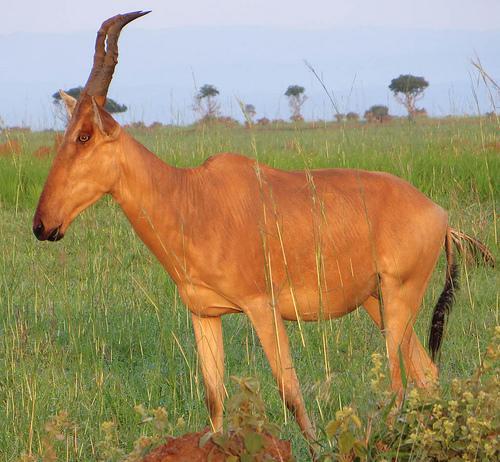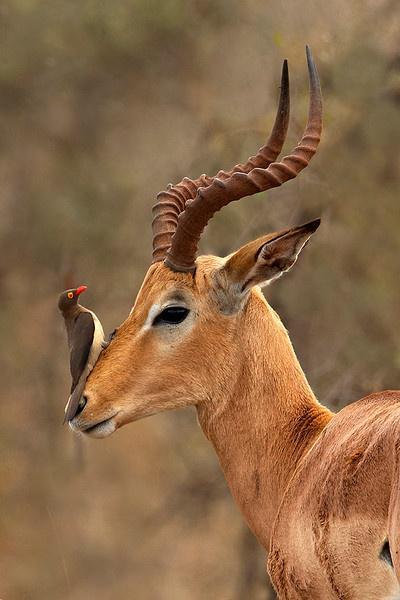The first image is the image on the left, the second image is the image on the right. Analyze the images presented: Is the assertion "At least 7 hartebeests walk down a dirt road." valid? Answer yes or no. No. The first image is the image on the left, the second image is the image on the right. For the images shown, is this caption "There are only two horned animals standing outside, one in each image." true? Answer yes or no. Yes. 